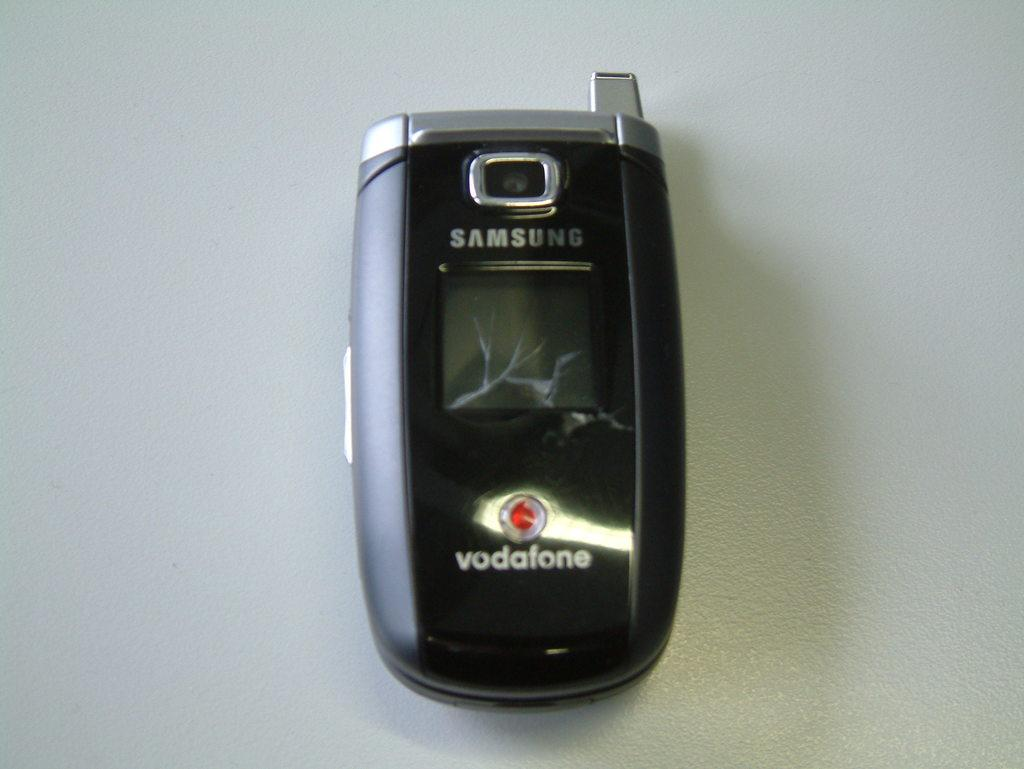<image>
Relay a brief, clear account of the picture shown. A Vodafone flip phone with a crack in the screen is closed. 